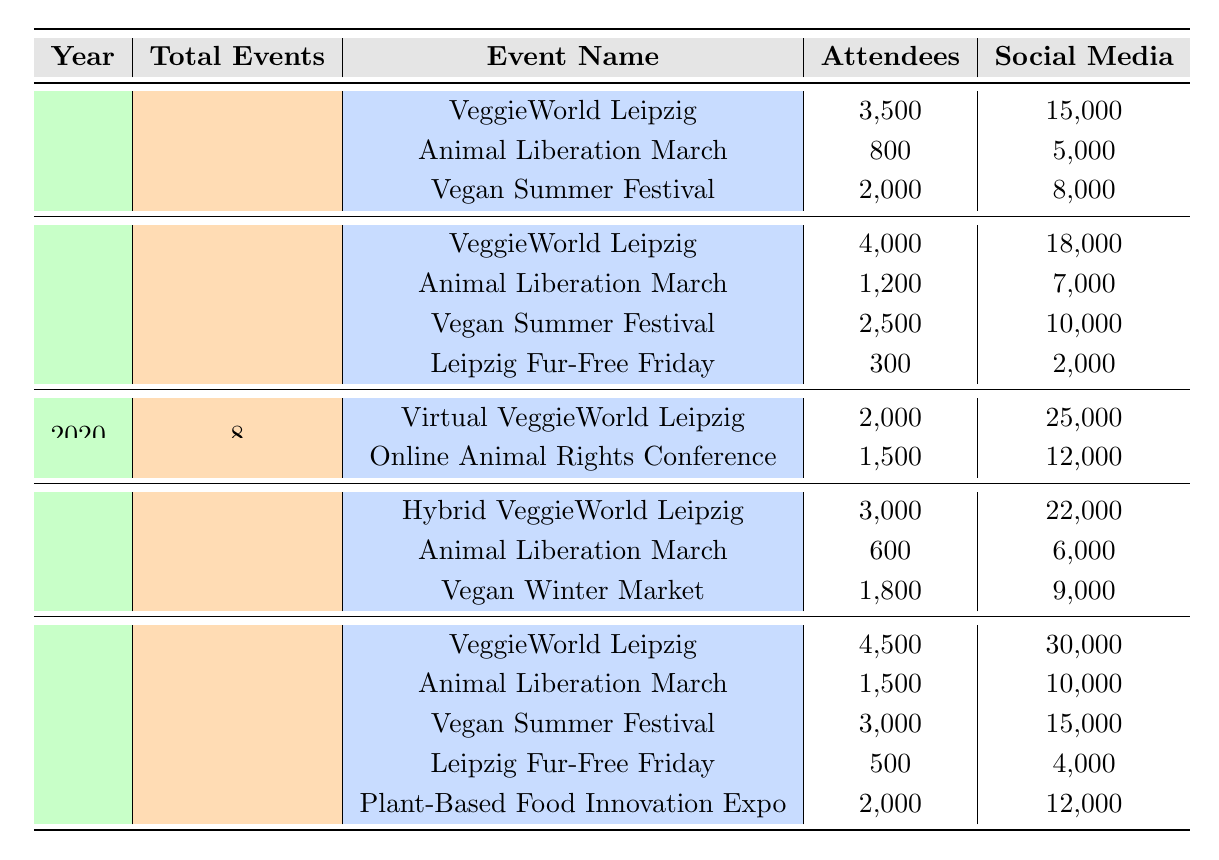What was the total number of attendees for all events in Leipzig in 2018? To find the total attendees for 2018, we sum the attendees from all events that year: 3500 (VeggieWorld) + 800 (Animal Liberation March) + 2000 (Vegan Summer Festival) = 6800.
Answer: 6800 Which event had the highest social media engagement in 2022? In 2022, the event with the highest social media engagement was the VeggieWorld Leipzig with 30,000 engagements.
Answer: VeggieWorld Leipzig How many total events were held in Leipzig from 2019 to 2022? We need to add the total events per year from 2019 to 2022: 15 (2019) + 8 (2020) + 10 (2021) + 18 (2022) = 51 total events.
Answer: 51 Did the number of attendees increase from 2019 to 2020 for the VeggieWorld? In 2019, VeggieWorld had 4000 attendees, and in 2020 it had 2000. Therefore, the number of attendees decreased from 2019 to 2020.
Answer: No What is the average number of volunteer sign-ups across all years? To find the average, first sum all volunteer sign-ups: 45 (2018) + 20 (2018) + 30 (2018) + 55 (2019) + 25 (2019) + 10 (2019) + 30 (2020) + 35 (2020) + 50 (2021) + 15 (2021) + 25 (2021) + 70 (2022) + 35 (2022) + 50 (2022) + 15 (2022) + 40 (2022) = 455. There were 16 events contributing, so 455/16 = 28.4375, rounded to 28.44.
Answer: 28.44 Which year had the least total events, and how many were there? The year with the least total events was 2020, with only 8 events held.
Answer: 2020, 8 events What is the difference in total social media engagement between 2018 and 2021? First, calculate total social media engagement for each year: 2018 = 15000 + 5000 + 8000 = 28000; 2021 = 22000 + 6000 + 9000 = 37000. The difference is 37000 - 28000 = 9000.
Answer: 9000 In which year did the Animal Liberation March have the most attendees? The Animal Liberation March had the following attendees: 800 in 2018, 1200 in 2019, 600 in 2021, and 1500 in 2022. The highest was in 2022 with 1500 attendees.
Answer: 2022 How did the number of events change from 2018 to 2022? In 2018 there were 12 events, while in 2022 there were 18 events. The change is an increase of 6 events.
Answer: Increase of 6 events Which event had the lowest attendance across all years? The lowest attendance was at Leipzig Fur-Free Friday in 2019 with 300 attendees.
Answer: Leipzig Fur-Free Friday, 300 attendees What was the total number of social media engagements for all events in 2020? For 2020, the total social media engagement is: 25000 (Virtual VeggieWorld) + 12000 (Online Animal Rights Conference) = 37000.
Answer: 37000 